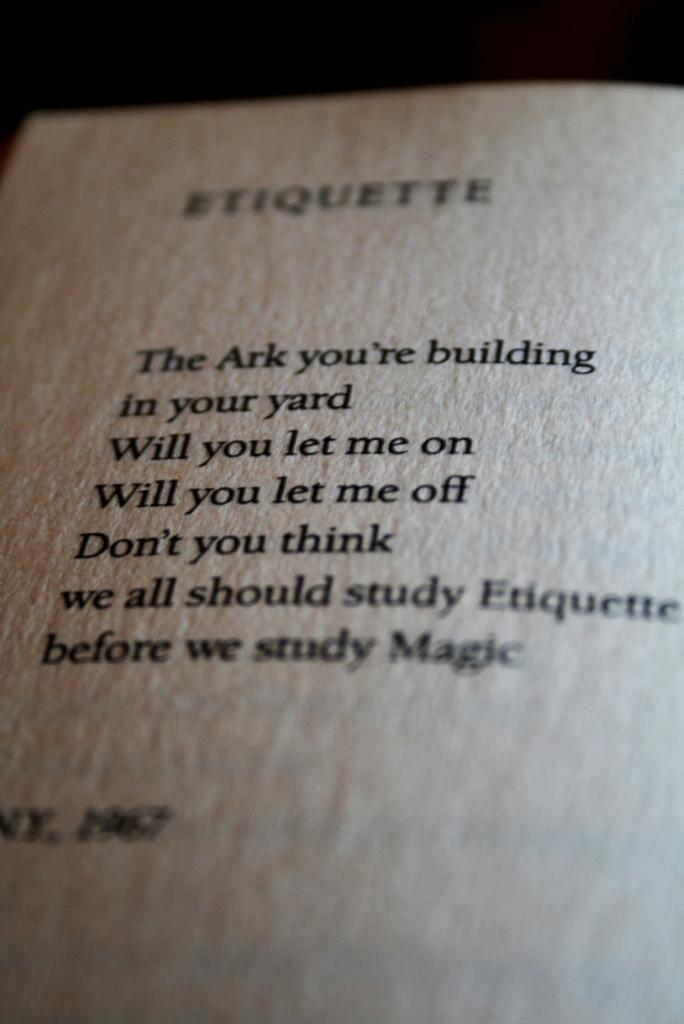<image>
Create a compact narrative representing the image presented. A page from a book with the title Etiquette and some sentences beneath 